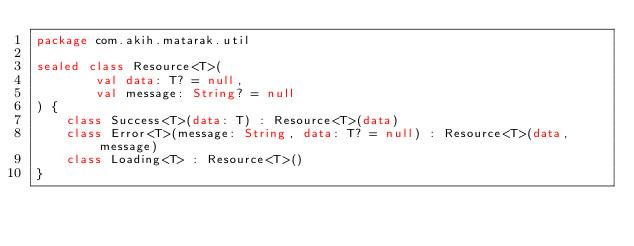Convert code to text. <code><loc_0><loc_0><loc_500><loc_500><_Kotlin_>package com.akih.matarak.util

sealed class Resource<T>(
        val data: T? = null,
        val message: String? = null
) {
    class Success<T>(data: T) : Resource<T>(data)
    class Error<T>(message: String, data: T? = null) : Resource<T>(data, message)
    class Loading<T> : Resource<T>()
}</code> 